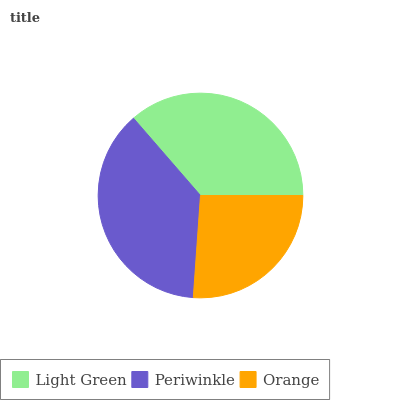Is Orange the minimum?
Answer yes or no. Yes. Is Periwinkle the maximum?
Answer yes or no. Yes. Is Periwinkle the minimum?
Answer yes or no. No. Is Orange the maximum?
Answer yes or no. No. Is Periwinkle greater than Orange?
Answer yes or no. Yes. Is Orange less than Periwinkle?
Answer yes or no. Yes. Is Orange greater than Periwinkle?
Answer yes or no. No. Is Periwinkle less than Orange?
Answer yes or no. No. Is Light Green the high median?
Answer yes or no. Yes. Is Light Green the low median?
Answer yes or no. Yes. Is Periwinkle the high median?
Answer yes or no. No. Is Periwinkle the low median?
Answer yes or no. No. 